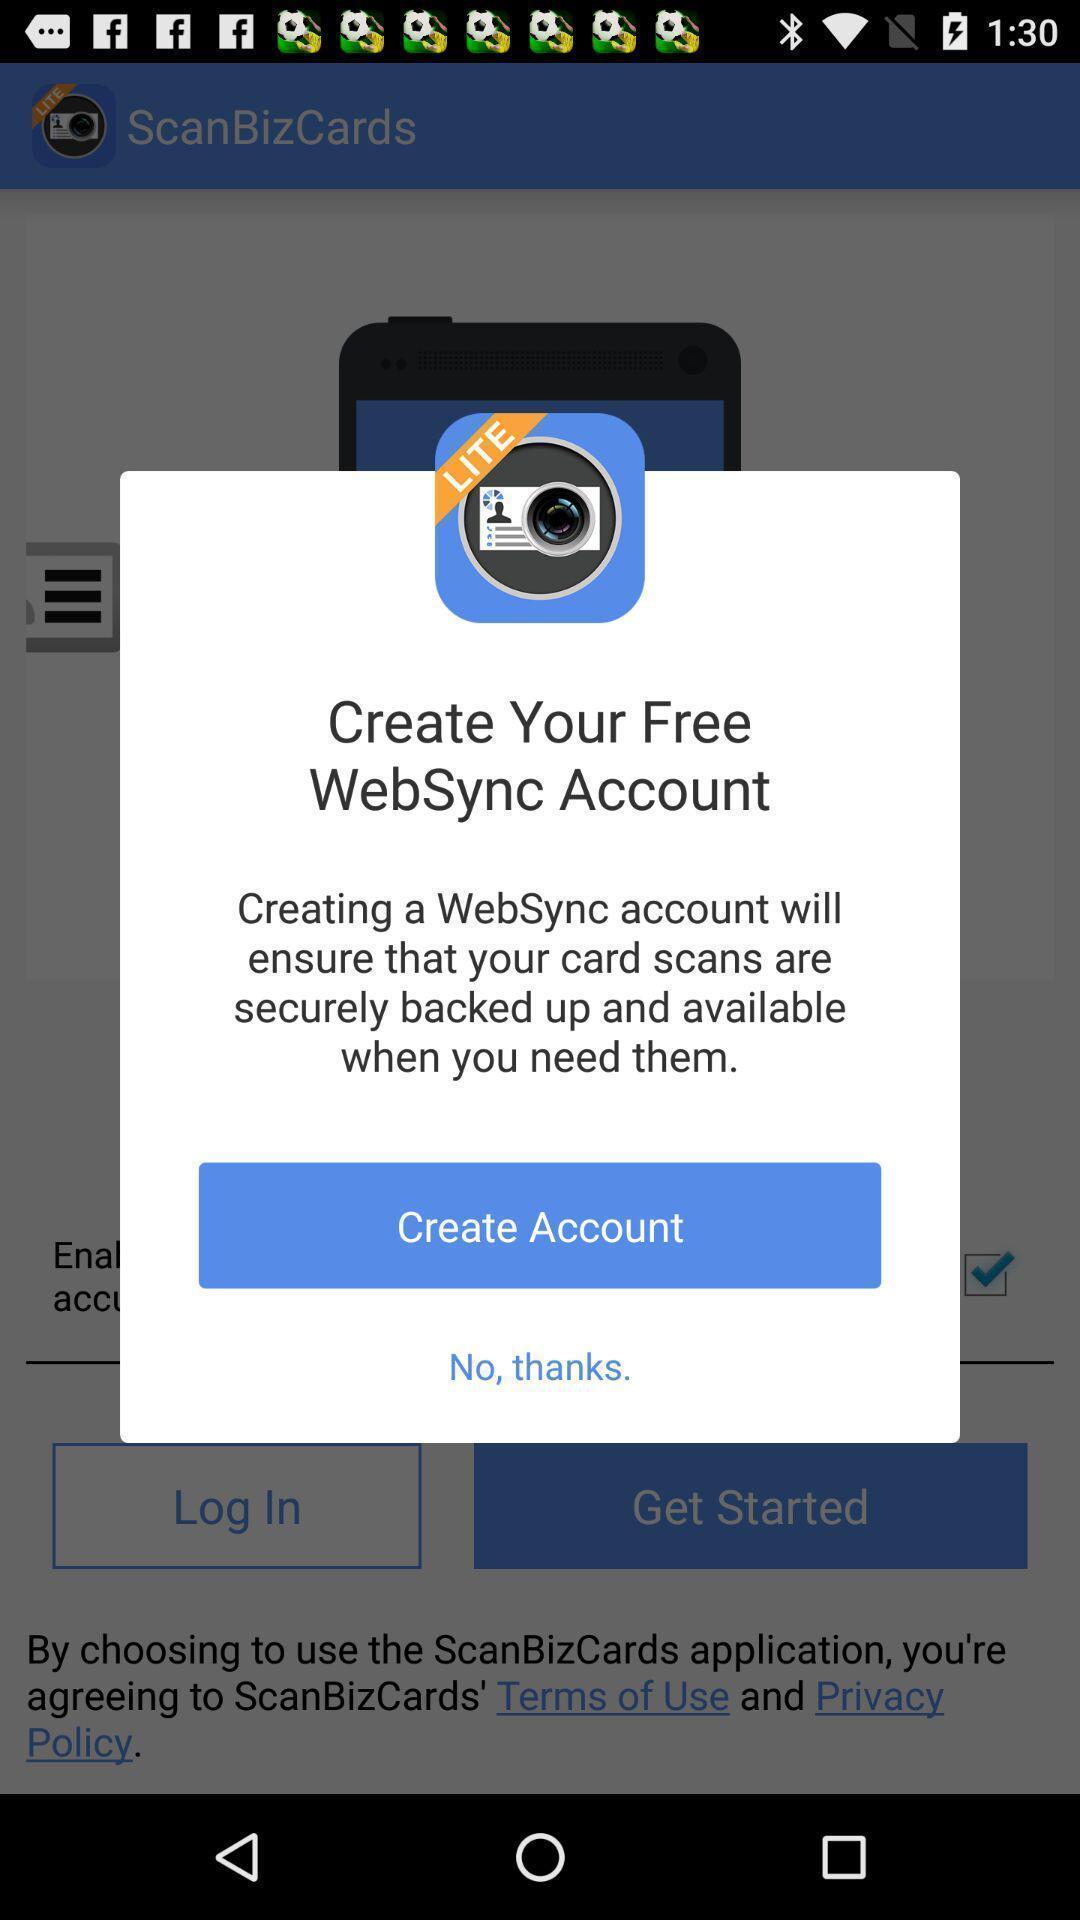Summarize the main components in this picture. Pop-up for the business application. 